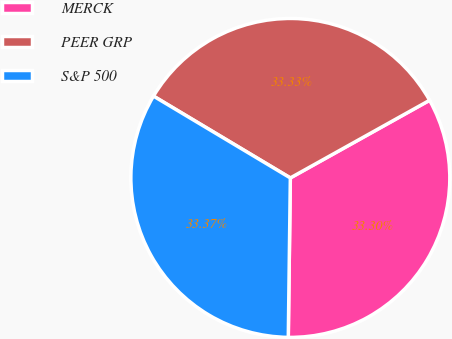<chart> <loc_0><loc_0><loc_500><loc_500><pie_chart><fcel>MERCK<fcel>PEER GRP<fcel>S&P 500<nl><fcel>33.3%<fcel>33.33%<fcel>33.37%<nl></chart> 